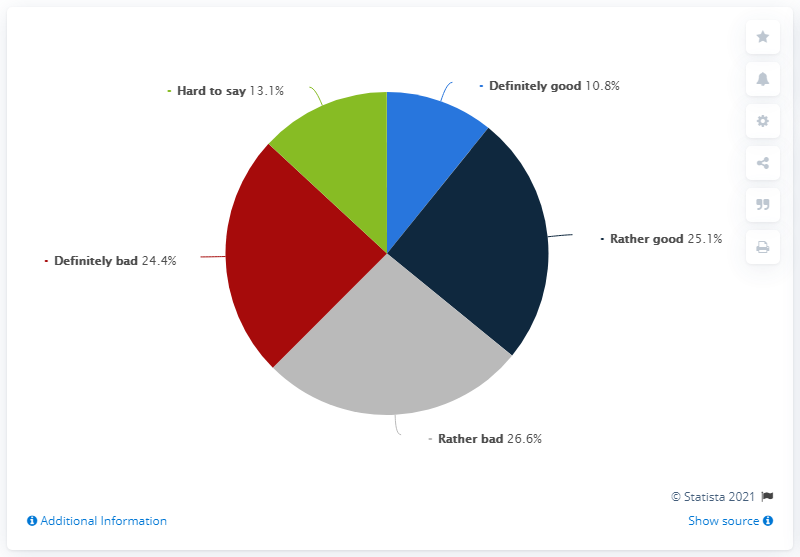Draw attention to some important aspects in this diagram. According to the data, 35.9% of people believe that it is at least good to open schools in September under the conditions presented by the government. According to the survey, 24.4% of the people indicated that the decision to open schools in September under the current conditions presented by the government is definitely bad. 